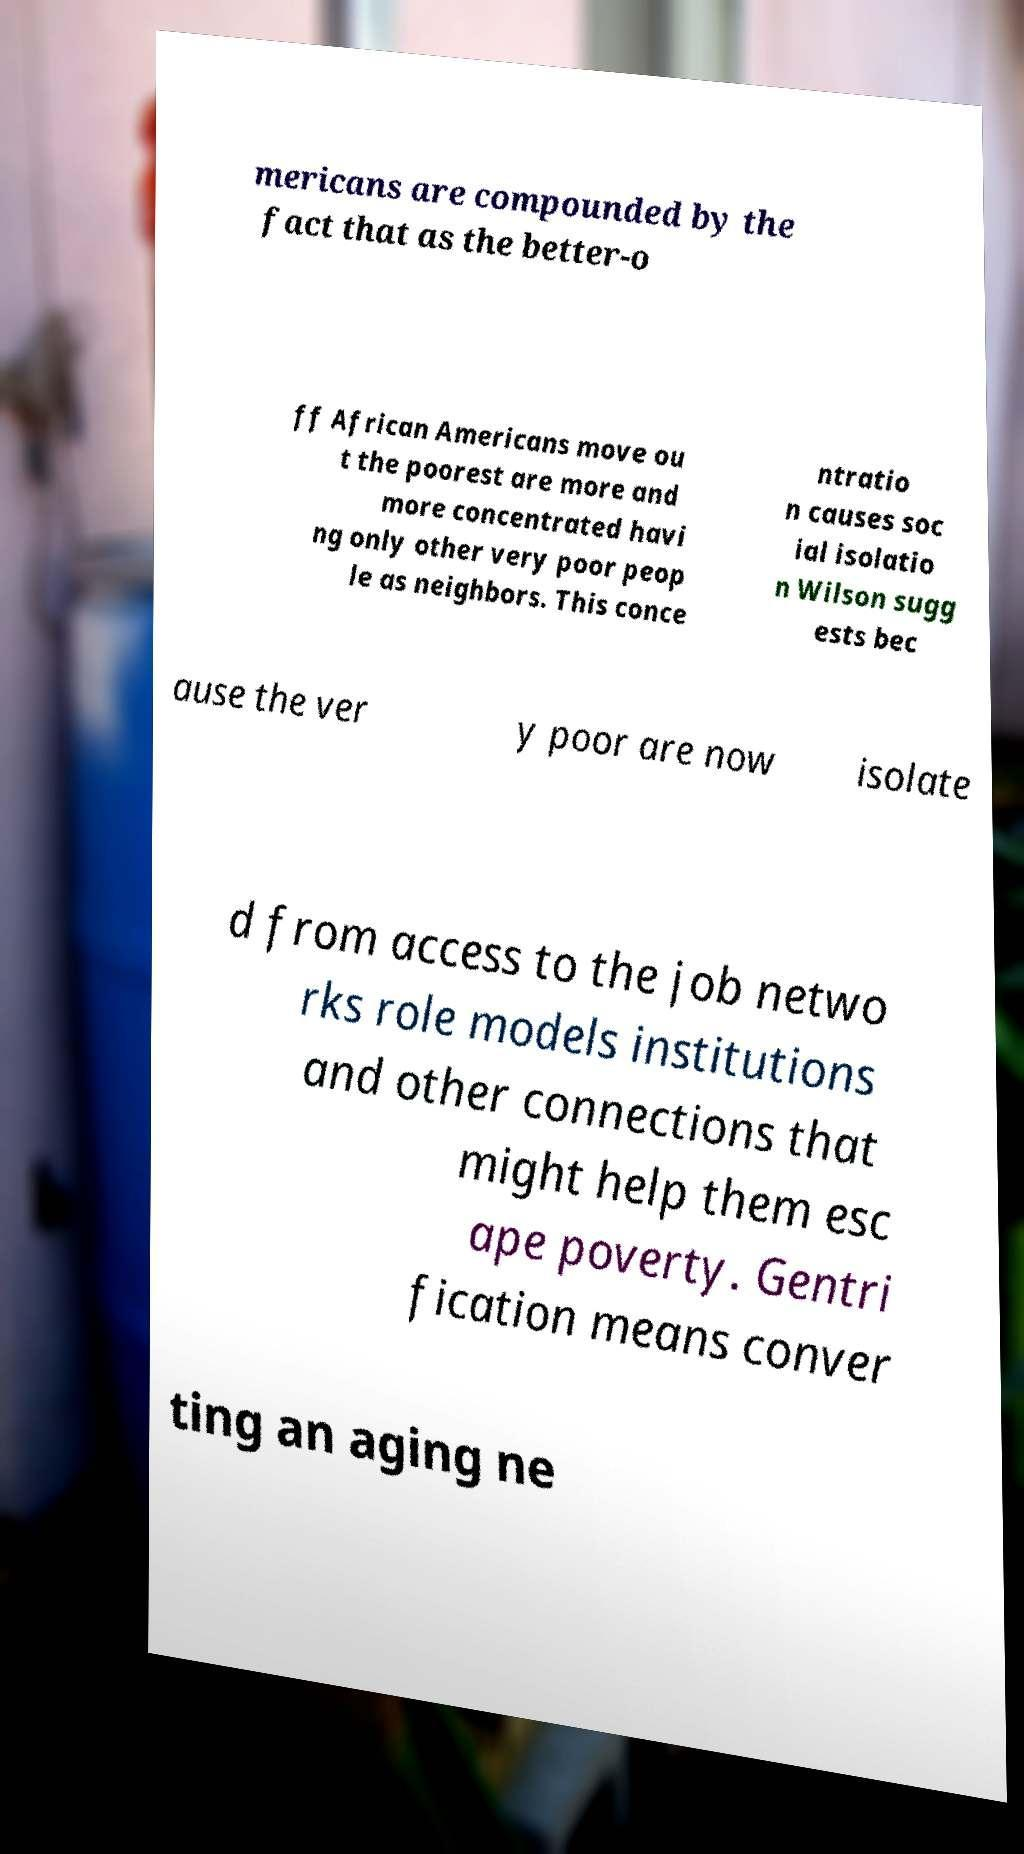I need the written content from this picture converted into text. Can you do that? mericans are compounded by the fact that as the better-o ff African Americans move ou t the poorest are more and more concentrated havi ng only other very poor peop le as neighbors. This conce ntratio n causes soc ial isolatio n Wilson sugg ests bec ause the ver y poor are now isolate d from access to the job netwo rks role models institutions and other connections that might help them esc ape poverty. Gentri fication means conver ting an aging ne 